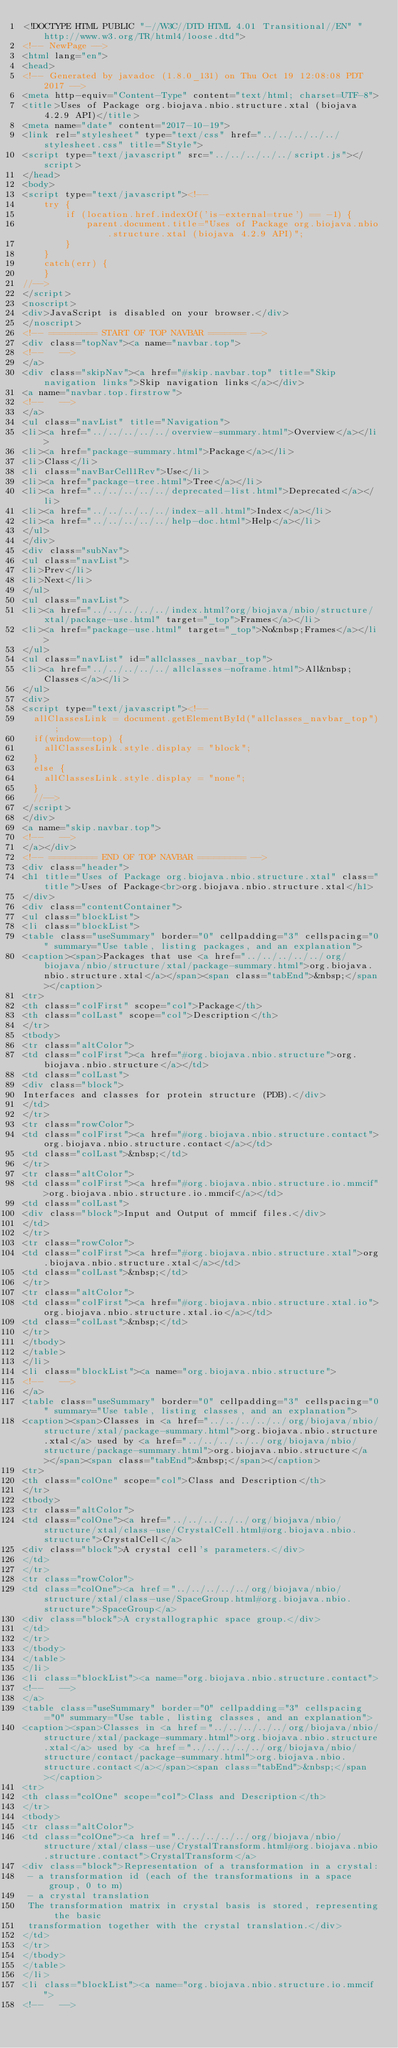Convert code to text. <code><loc_0><loc_0><loc_500><loc_500><_HTML_><!DOCTYPE HTML PUBLIC "-//W3C//DTD HTML 4.01 Transitional//EN" "http://www.w3.org/TR/html4/loose.dtd">
<!-- NewPage -->
<html lang="en">
<head>
<!-- Generated by javadoc (1.8.0_131) on Thu Oct 19 12:08:08 PDT 2017 -->
<meta http-equiv="Content-Type" content="text/html; charset=UTF-8">
<title>Uses of Package org.biojava.nbio.structure.xtal (biojava 4.2.9 API)</title>
<meta name="date" content="2017-10-19">
<link rel="stylesheet" type="text/css" href="../../../../../stylesheet.css" title="Style">
<script type="text/javascript" src="../../../../../script.js"></script>
</head>
<body>
<script type="text/javascript"><!--
    try {
        if (location.href.indexOf('is-external=true') == -1) {
            parent.document.title="Uses of Package org.biojava.nbio.structure.xtal (biojava 4.2.9 API)";
        }
    }
    catch(err) {
    }
//-->
</script>
<noscript>
<div>JavaScript is disabled on your browser.</div>
</noscript>
<!-- ========= START OF TOP NAVBAR ======= -->
<div class="topNav"><a name="navbar.top">
<!--   -->
</a>
<div class="skipNav"><a href="#skip.navbar.top" title="Skip navigation links">Skip navigation links</a></div>
<a name="navbar.top.firstrow">
<!--   -->
</a>
<ul class="navList" title="Navigation">
<li><a href="../../../../../overview-summary.html">Overview</a></li>
<li><a href="package-summary.html">Package</a></li>
<li>Class</li>
<li class="navBarCell1Rev">Use</li>
<li><a href="package-tree.html">Tree</a></li>
<li><a href="../../../../../deprecated-list.html">Deprecated</a></li>
<li><a href="../../../../../index-all.html">Index</a></li>
<li><a href="../../../../../help-doc.html">Help</a></li>
</ul>
</div>
<div class="subNav">
<ul class="navList">
<li>Prev</li>
<li>Next</li>
</ul>
<ul class="navList">
<li><a href="../../../../../index.html?org/biojava/nbio/structure/xtal/package-use.html" target="_top">Frames</a></li>
<li><a href="package-use.html" target="_top">No&nbsp;Frames</a></li>
</ul>
<ul class="navList" id="allclasses_navbar_top">
<li><a href="../../../../../allclasses-noframe.html">All&nbsp;Classes</a></li>
</ul>
<div>
<script type="text/javascript"><!--
  allClassesLink = document.getElementById("allclasses_navbar_top");
  if(window==top) {
    allClassesLink.style.display = "block";
  }
  else {
    allClassesLink.style.display = "none";
  }
  //-->
</script>
</div>
<a name="skip.navbar.top">
<!--   -->
</a></div>
<!-- ========= END OF TOP NAVBAR ========= -->
<div class="header">
<h1 title="Uses of Package org.biojava.nbio.structure.xtal" class="title">Uses of Package<br>org.biojava.nbio.structure.xtal</h1>
</div>
<div class="contentContainer">
<ul class="blockList">
<li class="blockList">
<table class="useSummary" border="0" cellpadding="3" cellspacing="0" summary="Use table, listing packages, and an explanation">
<caption><span>Packages that use <a href="../../../../../org/biojava/nbio/structure/xtal/package-summary.html">org.biojava.nbio.structure.xtal</a></span><span class="tabEnd">&nbsp;</span></caption>
<tr>
<th class="colFirst" scope="col">Package</th>
<th class="colLast" scope="col">Description</th>
</tr>
<tbody>
<tr class="altColor">
<td class="colFirst"><a href="#org.biojava.nbio.structure">org.biojava.nbio.structure</a></td>
<td class="colLast">
<div class="block">
Interfaces and classes for protein structure (PDB).</div>
</td>
</tr>
<tr class="rowColor">
<td class="colFirst"><a href="#org.biojava.nbio.structure.contact">org.biojava.nbio.structure.contact</a></td>
<td class="colLast">&nbsp;</td>
</tr>
<tr class="altColor">
<td class="colFirst"><a href="#org.biojava.nbio.structure.io.mmcif">org.biojava.nbio.structure.io.mmcif</a></td>
<td class="colLast">
<div class="block">Input and Output of mmcif files.</div>
</td>
</tr>
<tr class="rowColor">
<td class="colFirst"><a href="#org.biojava.nbio.structure.xtal">org.biojava.nbio.structure.xtal</a></td>
<td class="colLast">&nbsp;</td>
</tr>
<tr class="altColor">
<td class="colFirst"><a href="#org.biojava.nbio.structure.xtal.io">org.biojava.nbio.structure.xtal.io</a></td>
<td class="colLast">&nbsp;</td>
</tr>
</tbody>
</table>
</li>
<li class="blockList"><a name="org.biojava.nbio.structure">
<!--   -->
</a>
<table class="useSummary" border="0" cellpadding="3" cellspacing="0" summary="Use table, listing classes, and an explanation">
<caption><span>Classes in <a href="../../../../../org/biojava/nbio/structure/xtal/package-summary.html">org.biojava.nbio.structure.xtal</a> used by <a href="../../../../../org/biojava/nbio/structure/package-summary.html">org.biojava.nbio.structure</a></span><span class="tabEnd">&nbsp;</span></caption>
<tr>
<th class="colOne" scope="col">Class and Description</th>
</tr>
<tbody>
<tr class="altColor">
<td class="colOne"><a href="../../../../../org/biojava/nbio/structure/xtal/class-use/CrystalCell.html#org.biojava.nbio.structure">CrystalCell</a>
<div class="block">A crystal cell's parameters.</div>
</td>
</tr>
<tr class="rowColor">
<td class="colOne"><a href="../../../../../org/biojava/nbio/structure/xtal/class-use/SpaceGroup.html#org.biojava.nbio.structure">SpaceGroup</a>
<div class="block">A crystallographic space group.</div>
</td>
</tr>
</tbody>
</table>
</li>
<li class="blockList"><a name="org.biojava.nbio.structure.contact">
<!--   -->
</a>
<table class="useSummary" border="0" cellpadding="3" cellspacing="0" summary="Use table, listing classes, and an explanation">
<caption><span>Classes in <a href="../../../../../org/biojava/nbio/structure/xtal/package-summary.html">org.biojava.nbio.structure.xtal</a> used by <a href="../../../../../org/biojava/nbio/structure/contact/package-summary.html">org.biojava.nbio.structure.contact</a></span><span class="tabEnd">&nbsp;</span></caption>
<tr>
<th class="colOne" scope="col">Class and Description</th>
</tr>
<tbody>
<tr class="altColor">
<td class="colOne"><a href="../../../../../org/biojava/nbio/structure/xtal/class-use/CrystalTransform.html#org.biojava.nbio.structure.contact">CrystalTransform</a>
<div class="block">Representation of a transformation in a crystal:
 - a transformation id (each of the transformations in a space group, 0 to m)
 - a crystal translation
 The transformation matrix in crystal basis is stored, representing the basic
 transformation together with the crystal translation.</div>
</td>
</tr>
</tbody>
</table>
</li>
<li class="blockList"><a name="org.biojava.nbio.structure.io.mmcif">
<!--   --></code> 